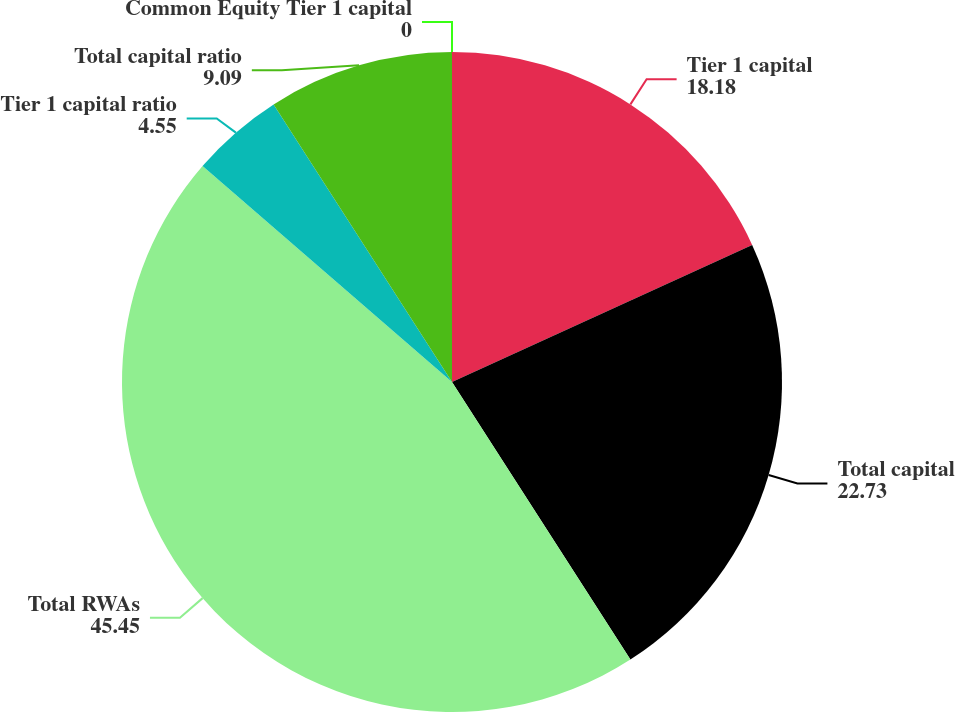Convert chart to OTSL. <chart><loc_0><loc_0><loc_500><loc_500><pie_chart><fcel>Common Equity Tier 1 capital<fcel>Tier 1 capital<fcel>Total capital<fcel>Total RWAs<fcel>Tier 1 capital ratio<fcel>Total capital ratio<nl><fcel>0.0%<fcel>18.18%<fcel>22.73%<fcel>45.45%<fcel>4.55%<fcel>9.09%<nl></chart> 